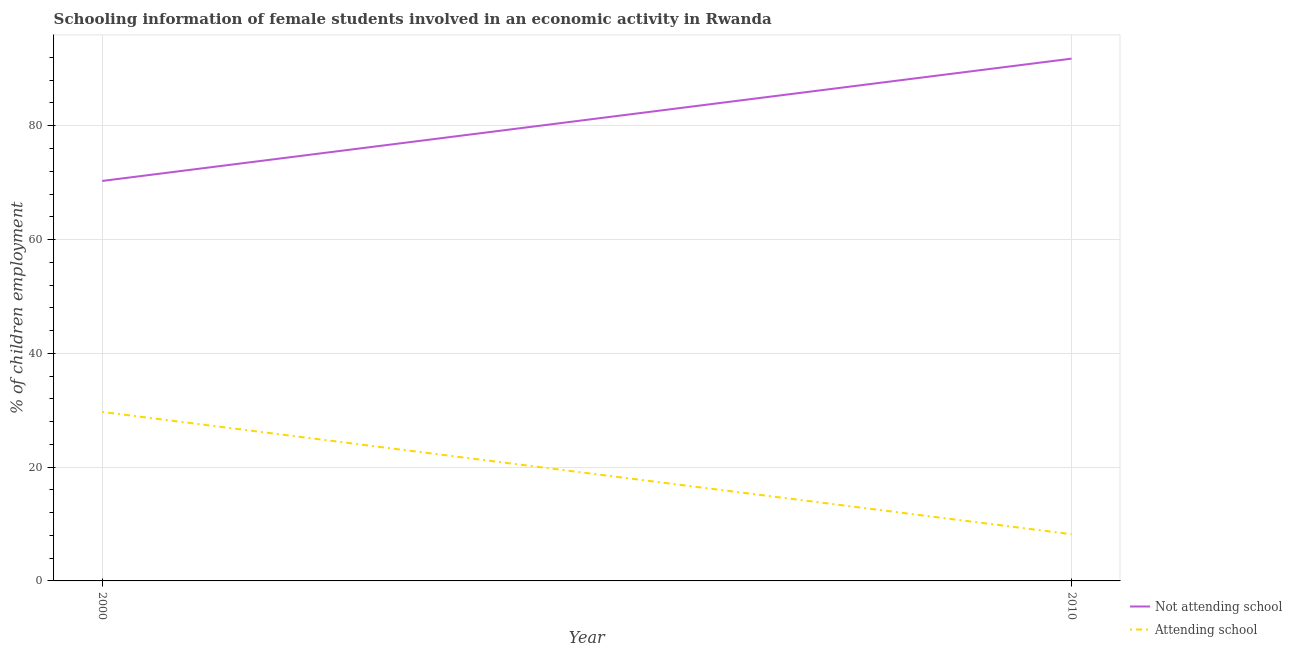Does the line corresponding to percentage of employed females who are not attending school intersect with the line corresponding to percentage of employed females who are attending school?
Keep it short and to the point. No. Is the number of lines equal to the number of legend labels?
Your answer should be very brief. Yes. What is the percentage of employed females who are attending school in 2000?
Make the answer very short. 29.7. Across all years, what is the maximum percentage of employed females who are not attending school?
Offer a terse response. 91.79. Across all years, what is the minimum percentage of employed females who are not attending school?
Your response must be concise. 70.3. In which year was the percentage of employed females who are not attending school maximum?
Provide a succinct answer. 2010. In which year was the percentage of employed females who are not attending school minimum?
Make the answer very short. 2000. What is the total percentage of employed females who are not attending school in the graph?
Offer a terse response. 162.09. What is the difference between the percentage of employed females who are not attending school in 2000 and that in 2010?
Offer a very short reply. -21.49. What is the difference between the percentage of employed females who are attending school in 2010 and the percentage of employed females who are not attending school in 2000?
Offer a very short reply. -62.09. What is the average percentage of employed females who are attending school per year?
Provide a succinct answer. 18.96. In the year 2010, what is the difference between the percentage of employed females who are not attending school and percentage of employed females who are attending school?
Your response must be concise. 83.58. In how many years, is the percentage of employed females who are not attending school greater than 4 %?
Provide a succinct answer. 2. What is the ratio of the percentage of employed females who are attending school in 2000 to that in 2010?
Make the answer very short. 3.62. In how many years, is the percentage of employed females who are attending school greater than the average percentage of employed females who are attending school taken over all years?
Your answer should be compact. 1. Does the percentage of employed females who are not attending school monotonically increase over the years?
Ensure brevity in your answer.  Yes. Is the percentage of employed females who are not attending school strictly greater than the percentage of employed females who are attending school over the years?
Offer a very short reply. Yes. Is the percentage of employed females who are not attending school strictly less than the percentage of employed females who are attending school over the years?
Make the answer very short. No. How many lines are there?
Offer a terse response. 2. What is the difference between two consecutive major ticks on the Y-axis?
Offer a very short reply. 20. Are the values on the major ticks of Y-axis written in scientific E-notation?
Your answer should be very brief. No. Where does the legend appear in the graph?
Your answer should be compact. Bottom right. What is the title of the graph?
Provide a succinct answer. Schooling information of female students involved in an economic activity in Rwanda. What is the label or title of the Y-axis?
Provide a short and direct response. % of children employment. What is the % of children employment of Not attending school in 2000?
Your answer should be very brief. 70.3. What is the % of children employment in Attending school in 2000?
Provide a short and direct response. 29.7. What is the % of children employment in Not attending school in 2010?
Offer a very short reply. 91.79. What is the % of children employment of Attending school in 2010?
Provide a short and direct response. 8.21. Across all years, what is the maximum % of children employment of Not attending school?
Offer a terse response. 91.79. Across all years, what is the maximum % of children employment of Attending school?
Your answer should be very brief. 29.7. Across all years, what is the minimum % of children employment of Not attending school?
Make the answer very short. 70.3. Across all years, what is the minimum % of children employment of Attending school?
Give a very brief answer. 8.21. What is the total % of children employment in Not attending school in the graph?
Provide a succinct answer. 162.09. What is the total % of children employment of Attending school in the graph?
Provide a short and direct response. 37.91. What is the difference between the % of children employment of Not attending school in 2000 and that in 2010?
Provide a short and direct response. -21.49. What is the difference between the % of children employment of Attending school in 2000 and that in 2010?
Your answer should be very brief. 21.49. What is the difference between the % of children employment in Not attending school in 2000 and the % of children employment in Attending school in 2010?
Make the answer very short. 62.09. What is the average % of children employment of Not attending school per year?
Give a very brief answer. 81.04. What is the average % of children employment of Attending school per year?
Provide a succinct answer. 18.96. In the year 2000, what is the difference between the % of children employment in Not attending school and % of children employment in Attending school?
Your answer should be compact. 40.59. In the year 2010, what is the difference between the % of children employment in Not attending school and % of children employment in Attending school?
Your response must be concise. 83.58. What is the ratio of the % of children employment of Not attending school in 2000 to that in 2010?
Provide a succinct answer. 0.77. What is the ratio of the % of children employment in Attending school in 2000 to that in 2010?
Ensure brevity in your answer.  3.62. What is the difference between the highest and the second highest % of children employment in Not attending school?
Provide a succinct answer. 21.49. What is the difference between the highest and the second highest % of children employment of Attending school?
Your answer should be compact. 21.49. What is the difference between the highest and the lowest % of children employment in Not attending school?
Make the answer very short. 21.49. What is the difference between the highest and the lowest % of children employment of Attending school?
Offer a very short reply. 21.49. 